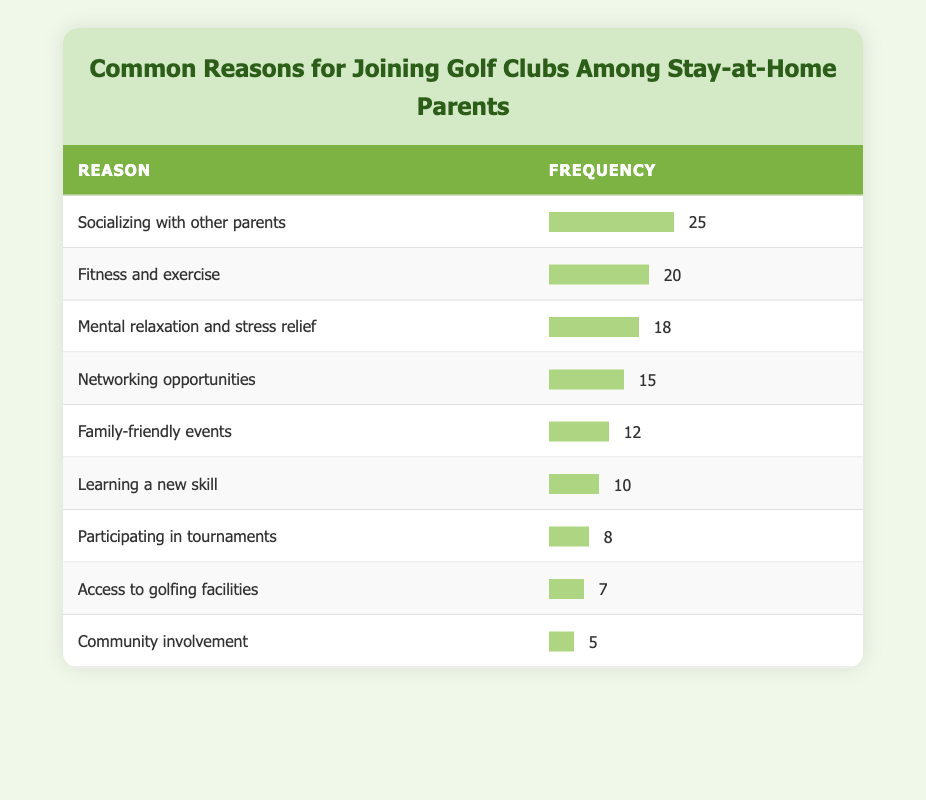What is the most common reason for joining golf clubs among stay-at-home parents? According to the table, "Socializing with other parents" has the highest frequency of 25, which indicates that it is the most common reason.
Answer: Socializing with other parents What is the frequency of family-friendly events as a reason for joining golf clubs? The table shows that "Family-friendly events" has a frequency of 12.
Answer: 12 What is the total frequency of reasons related to social aspects (socializing with other parents and networking opportunities)? Adding the frequencies of "Socializing with other parents" (25) and "Networking opportunities" (15) gives a total of 25 + 15 = 40.
Answer: 40 Is there a reason for joining golf clubs that has a frequency higher than 20 but lower than 25? Looking at the frequencies, "Fitness and exercise" has a frequency of 20, which is less than 25, and there is no other reason with a value between those two numbers.
Answer: No What is the difference in frequency between the second most common reason and the third most common reason? The second most common reason is "Fitness and exercise" (20) and the third is "Mental relaxation and stress relief" (18). The difference is 20 - 18 = 2.
Answer: 2 Which reason has the lowest frequency, and what is that frequency? The lowest frequency is for "Community involvement," which stands at 5.
Answer: Community involvement, 5 What average frequency is associated with learning a new skill and participating in tournaments combined? Summing the frequencies for "Learning a new skill" (10) and "Participating in tournaments" (8) gives 10 + 8 = 18. Then, dividing by 2 gives an average of 18 / 2 = 9.
Answer: 9 How many reasons have a frequency of 10 or lower? The reasons with a frequency of 10 or lower are "Learning a new skill" (10), "Participating in tournaments" (8), "Access to golfing facilities" (7), and "Community involvement" (5): totaling four reasons.
Answer: 4 What percentage of parents joined for mental relaxation and stress relief compared to those who joined for fitness and exercise? The frequency of "Mental relaxation and stress relief" is 18, while "Fitness and exercise" is 20. To find the percentage, divide 18 by 20 and multiply by 100, which results in (18/20) * 100 = 90%.
Answer: 90% 